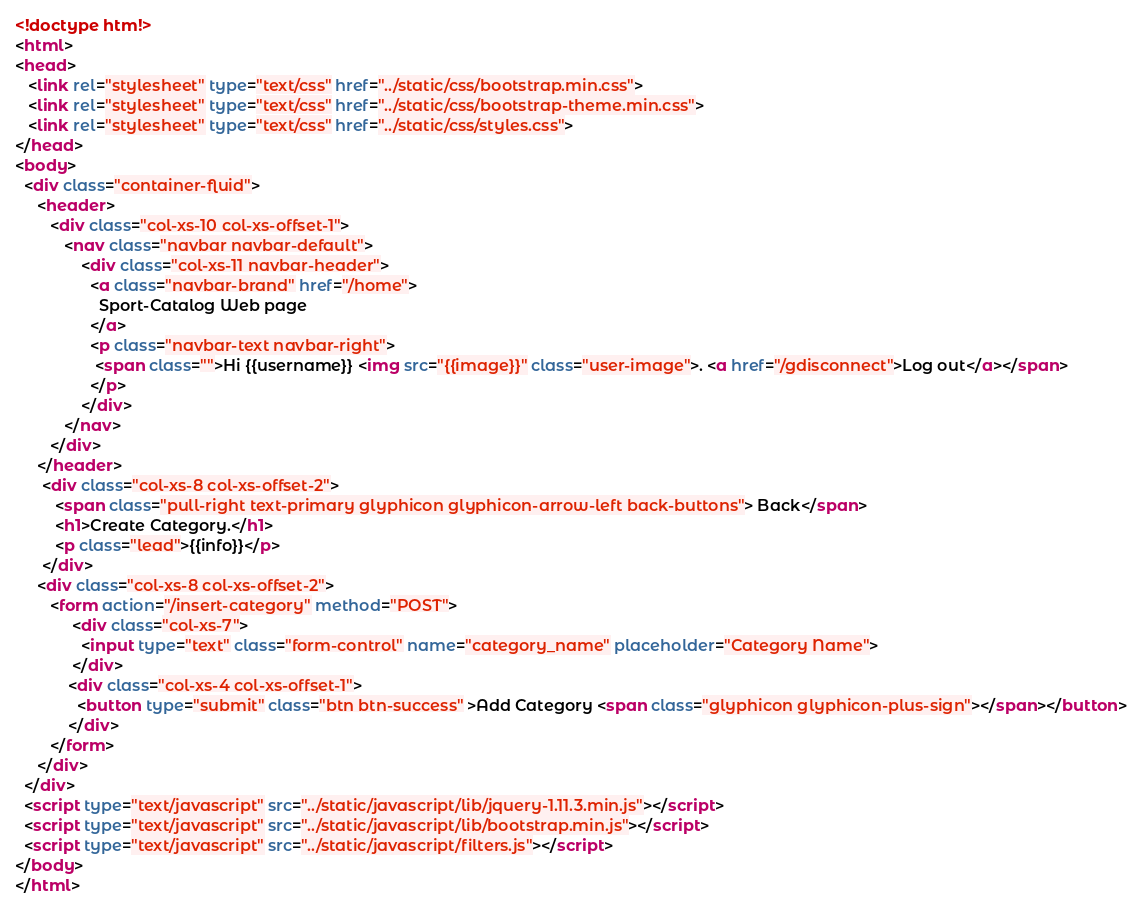<code> <loc_0><loc_0><loc_500><loc_500><_HTML_><!doctype htm!>
<html>
<head>
   <link rel="stylesheet" type="text/css" href="../static/css/bootstrap.min.css">
   <link rel="stylesheet" type="text/css" href="../static/css/bootstrap-theme.min.css">
   <link rel="stylesheet" type="text/css" href="../static/css/styles.css">
</head>
<body>
  <div class="container-fluid">
     <header>
        <div class="col-xs-10 col-xs-offset-1">
           <nav class="navbar navbar-default">
               <div class="col-xs-11 navbar-header">
                 <a class="navbar-brand" href="/home">
                   Sport-Catalog Web page
                 </a>  
                 <p class="navbar-text navbar-right">
                  <span class="">Hi {{username}} <img src="{{image}}" class="user-image">. <a href="/gdisconnect">Log out</a></span>
                 </p>
               </div>
           </nav>
        </div>
     </header>
      <div class="col-xs-8 col-xs-offset-2">
         <span class="pull-right text-primary glyphicon glyphicon-arrow-left back-buttons"> Back</span>
         <h1>Create Category.</h1>
         <p class="lead">{{info}}</p>
      </div>
     <div class="col-xs-8 col-xs-offset-2">
        <form action="/insert-category" method="POST">
     		 <div class="col-xs-7">
     		   <input type="text" class="form-control" name="category_name" placeholder="Category Name">
     		 </div>
     	    <div class="col-xs-4 col-xs-offset-1">
     		  <button type="submit" class="btn btn-success" >Add Category <span class="glyphicon glyphicon-plus-sign"></span></button>
     	    </div>
        </form>
     </div>
  </div>
  <script type="text/javascript" src="../static/javascript/lib/jquery-1.11.3.min.js"></script>
  <script type="text/javascript" src="../static/javascript/lib/bootstrap.min.js"></script>
  <script type="text/javascript" src="../static/javascript/filters.js"></script>
</body>
</html></code> 